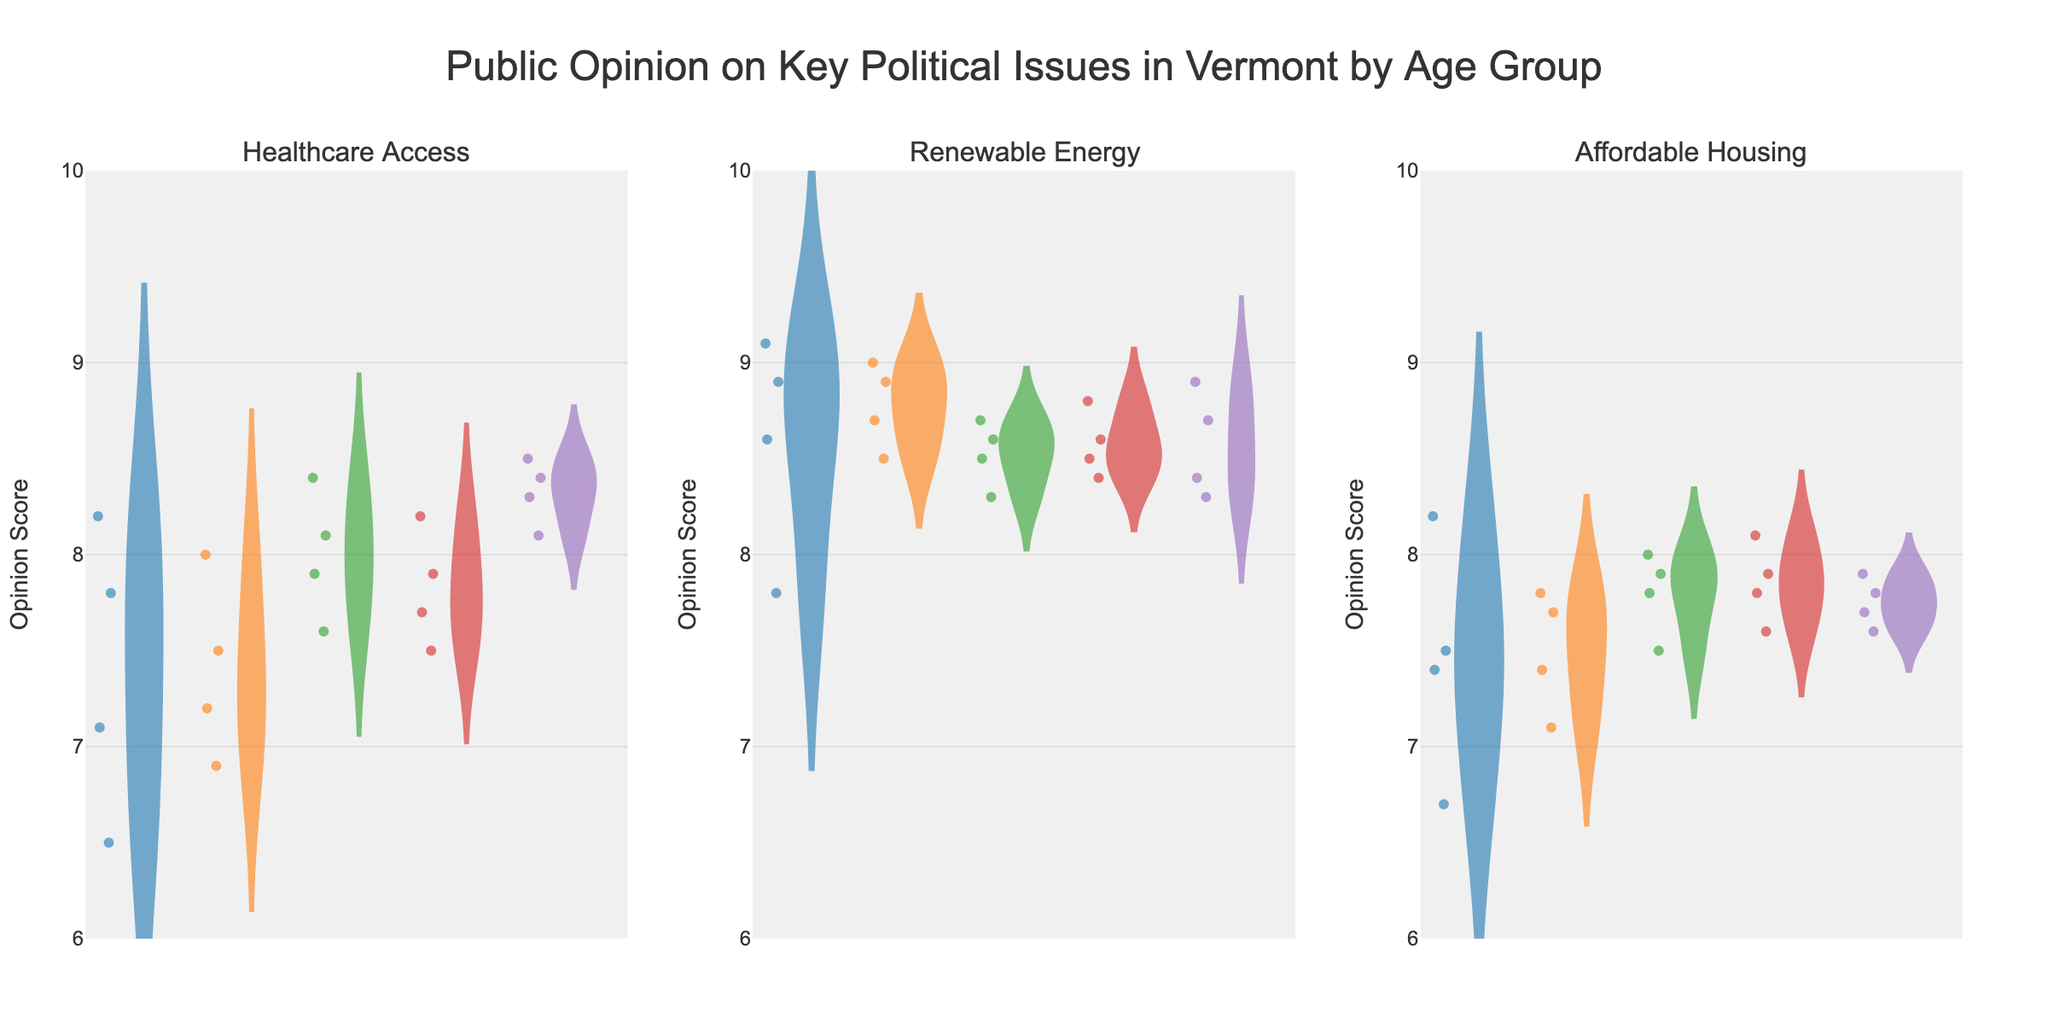What is the title of the chart? The title of the chart is displayed at the top. It reads: "Public Opinion on Key Political Issues in Vermont by Age Group."
Answer: Public Opinion on Key Political Issues in Vermont by Age Group How many subplots are in the figure? By counting the individual panels within the entire figure, there are three subplots.
Answer: Three Which age group shows the highest opinion score for Renewable Energy? By comparing the maximum values in the Renewable Energy subplot, the 18-25 age group appears to have the highest opinion score.
Answer: 18-25 What is the range of opinion scores for Healthcare Access for people aged 60+? The range of opinion scores for Healthcare Access for people aged 60+ can be determined by observing the lowest and highest points of the violin plot in that subplot.
Answer: 8.1 to 8.5 Which age group has the most consistent opinion on Affordable Housing? Look at the width and spread of the violin plots for Affordable Housing. The age group 60+ seems to have the narrowest plot, indicating more consistent opinions.
Answer: 60+ What is the average opinion score for Renewable Energy across all age groups? First, average the opinion scores for each age group under Renewable Energy and then find the overall average of these averages.
Answer: Approximately 8.65 Do people aged 46-60 have a higher opinion score for Healthcare Access or Affordable Housing? Compare the median lines of Healthcare Access and Affordable Housing for the 46-60 age group. The median for Healthcare Access is visibly higher than that for Affordable Housing.
Answer: Healthcare Access Which issue has the most varied opinion scores for the 26-35 age group? Compare the spread and range within each violin plot for the 26-35 age group. The variety seems greatest in Healthcare Access.
Answer: Healthcare Access How does the opinion score for Healthcare Access differ between the 18-25 and 60+ age groups? Subtract the average opinion score for Healthcare Access in the 18-25 group from the average in the 60+ group to find the difference. The values suggest the opinions of the older group are generally higher.
Answer: Higher by around 1 point What is the median opinion score for people aged 36-45 on Renewable Energy? The median can be identified by the line inside the violin plot. For the 36-45 age group on Renewable Energy, the median opinion score is around 8.6.
Answer: 8.6 